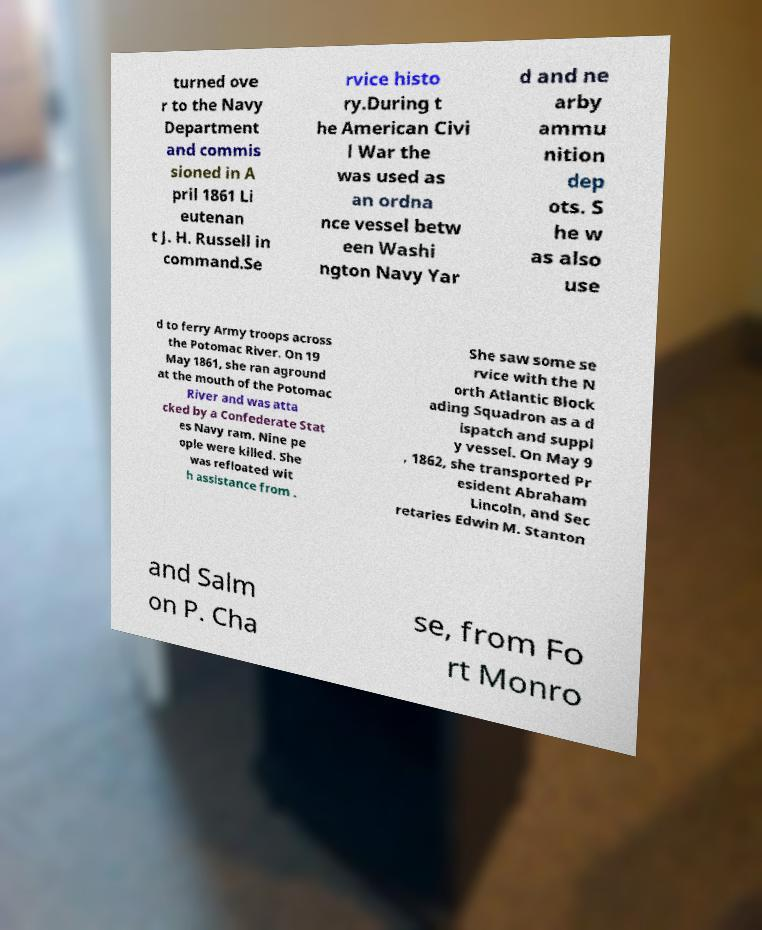Please identify and transcribe the text found in this image. turned ove r to the Navy Department and commis sioned in A pril 1861 Li eutenan t J. H. Russell in command.Se rvice histo ry.During t he American Civi l War the was used as an ordna nce vessel betw een Washi ngton Navy Yar d and ne arby ammu nition dep ots. S he w as also use d to ferry Army troops across the Potomac River. On 19 May 1861, she ran aground at the mouth of the Potomac River and was atta cked by a Confederate Stat es Navy ram. Nine pe ople were killed. She was refloated wit h assistance from . She saw some se rvice with the N orth Atlantic Block ading Squadron as a d ispatch and suppl y vessel. On May 9 , 1862, she transported Pr esident Abraham Lincoln, and Sec retaries Edwin M. Stanton and Salm on P. Cha se, from Fo rt Monro 